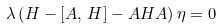Convert formula to latex. <formula><loc_0><loc_0><loc_500><loc_500>\lambda \left ( H - \left [ A , \, H \right ] - A H A \right ) \eta = 0</formula> 